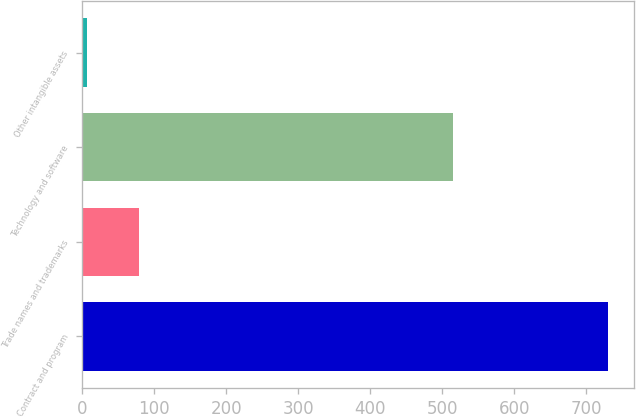<chart> <loc_0><loc_0><loc_500><loc_500><bar_chart><fcel>Contract and program<fcel>Trade names and trademarks<fcel>Technology and software<fcel>Other intangible assets<nl><fcel>730<fcel>79.3<fcel>515<fcel>7<nl></chart> 